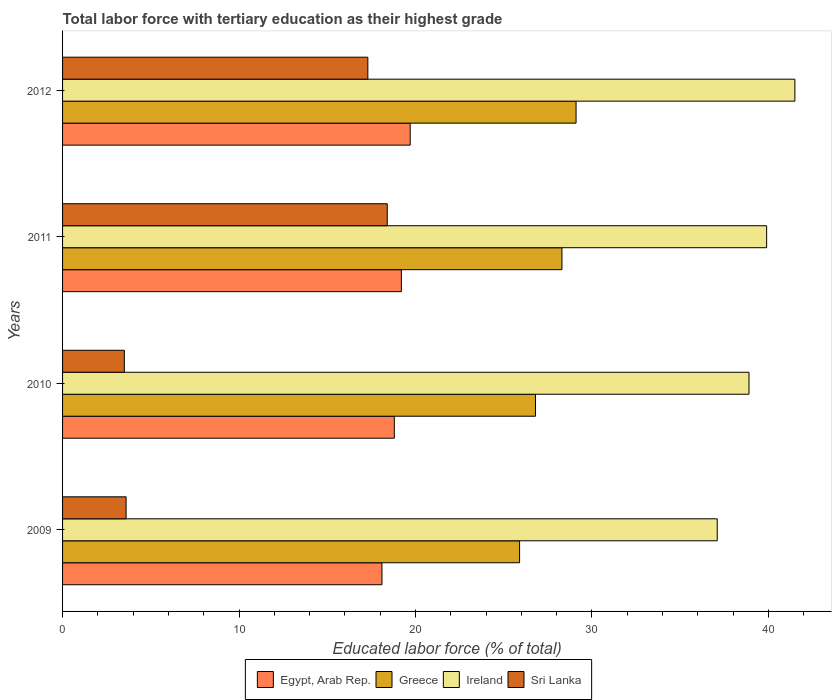How many groups of bars are there?
Your answer should be very brief. 4. Are the number of bars per tick equal to the number of legend labels?
Give a very brief answer. Yes. What is the percentage of male labor force with tertiary education in Ireland in 2009?
Provide a short and direct response. 37.1. Across all years, what is the maximum percentage of male labor force with tertiary education in Greece?
Offer a very short reply. 29.1. Across all years, what is the minimum percentage of male labor force with tertiary education in Sri Lanka?
Your answer should be compact. 3.5. What is the total percentage of male labor force with tertiary education in Ireland in the graph?
Your response must be concise. 157.4. What is the difference between the percentage of male labor force with tertiary education in Sri Lanka in 2009 and that in 2010?
Provide a succinct answer. 0.1. What is the difference between the percentage of male labor force with tertiary education in Egypt, Arab Rep. in 2009 and the percentage of male labor force with tertiary education in Greece in 2011?
Make the answer very short. -10.2. What is the average percentage of male labor force with tertiary education in Ireland per year?
Provide a succinct answer. 39.35. In the year 2011, what is the difference between the percentage of male labor force with tertiary education in Egypt, Arab Rep. and percentage of male labor force with tertiary education in Ireland?
Your answer should be compact. -20.7. What is the ratio of the percentage of male labor force with tertiary education in Greece in 2011 to that in 2012?
Your answer should be very brief. 0.97. Is the percentage of male labor force with tertiary education in Greece in 2009 less than that in 2011?
Offer a terse response. Yes. Is the difference between the percentage of male labor force with tertiary education in Egypt, Arab Rep. in 2011 and 2012 greater than the difference between the percentage of male labor force with tertiary education in Ireland in 2011 and 2012?
Offer a very short reply. Yes. What is the difference between the highest and the second highest percentage of male labor force with tertiary education in Greece?
Your answer should be very brief. 0.8. What is the difference between the highest and the lowest percentage of male labor force with tertiary education in Ireland?
Keep it short and to the point. 4.4. In how many years, is the percentage of male labor force with tertiary education in Egypt, Arab Rep. greater than the average percentage of male labor force with tertiary education in Egypt, Arab Rep. taken over all years?
Make the answer very short. 2. Is it the case that in every year, the sum of the percentage of male labor force with tertiary education in Ireland and percentage of male labor force with tertiary education in Egypt, Arab Rep. is greater than the sum of percentage of male labor force with tertiary education in Greece and percentage of male labor force with tertiary education in Sri Lanka?
Your response must be concise. No. What does the 3rd bar from the top in 2010 represents?
Provide a succinct answer. Greece. What does the 3rd bar from the bottom in 2009 represents?
Make the answer very short. Ireland. Is it the case that in every year, the sum of the percentage of male labor force with tertiary education in Sri Lanka and percentage of male labor force with tertiary education in Egypt, Arab Rep. is greater than the percentage of male labor force with tertiary education in Greece?
Your response must be concise. No. Are all the bars in the graph horizontal?
Offer a very short reply. Yes. How many years are there in the graph?
Keep it short and to the point. 4. Does the graph contain any zero values?
Provide a short and direct response. No. Where does the legend appear in the graph?
Your answer should be compact. Bottom center. What is the title of the graph?
Your answer should be compact. Total labor force with tertiary education as their highest grade. What is the label or title of the X-axis?
Keep it short and to the point. Educated labor force (% of total). What is the label or title of the Y-axis?
Give a very brief answer. Years. What is the Educated labor force (% of total) of Egypt, Arab Rep. in 2009?
Your answer should be very brief. 18.1. What is the Educated labor force (% of total) of Greece in 2009?
Provide a succinct answer. 25.9. What is the Educated labor force (% of total) of Ireland in 2009?
Your response must be concise. 37.1. What is the Educated labor force (% of total) in Sri Lanka in 2009?
Keep it short and to the point. 3.6. What is the Educated labor force (% of total) of Egypt, Arab Rep. in 2010?
Provide a short and direct response. 18.8. What is the Educated labor force (% of total) in Greece in 2010?
Make the answer very short. 26.8. What is the Educated labor force (% of total) of Ireland in 2010?
Make the answer very short. 38.9. What is the Educated labor force (% of total) in Sri Lanka in 2010?
Offer a terse response. 3.5. What is the Educated labor force (% of total) in Egypt, Arab Rep. in 2011?
Ensure brevity in your answer.  19.2. What is the Educated labor force (% of total) in Greece in 2011?
Provide a short and direct response. 28.3. What is the Educated labor force (% of total) of Ireland in 2011?
Keep it short and to the point. 39.9. What is the Educated labor force (% of total) of Sri Lanka in 2011?
Offer a very short reply. 18.4. What is the Educated labor force (% of total) of Egypt, Arab Rep. in 2012?
Your answer should be compact. 19.7. What is the Educated labor force (% of total) in Greece in 2012?
Give a very brief answer. 29.1. What is the Educated labor force (% of total) in Ireland in 2012?
Offer a very short reply. 41.5. What is the Educated labor force (% of total) in Sri Lanka in 2012?
Give a very brief answer. 17.3. Across all years, what is the maximum Educated labor force (% of total) in Egypt, Arab Rep.?
Keep it short and to the point. 19.7. Across all years, what is the maximum Educated labor force (% of total) in Greece?
Your answer should be compact. 29.1. Across all years, what is the maximum Educated labor force (% of total) in Ireland?
Make the answer very short. 41.5. Across all years, what is the maximum Educated labor force (% of total) of Sri Lanka?
Your answer should be compact. 18.4. Across all years, what is the minimum Educated labor force (% of total) of Egypt, Arab Rep.?
Your answer should be very brief. 18.1. Across all years, what is the minimum Educated labor force (% of total) in Greece?
Your response must be concise. 25.9. Across all years, what is the minimum Educated labor force (% of total) in Ireland?
Offer a very short reply. 37.1. Across all years, what is the minimum Educated labor force (% of total) in Sri Lanka?
Provide a succinct answer. 3.5. What is the total Educated labor force (% of total) in Egypt, Arab Rep. in the graph?
Provide a succinct answer. 75.8. What is the total Educated labor force (% of total) of Greece in the graph?
Provide a succinct answer. 110.1. What is the total Educated labor force (% of total) of Ireland in the graph?
Your answer should be compact. 157.4. What is the total Educated labor force (% of total) of Sri Lanka in the graph?
Your answer should be compact. 42.8. What is the difference between the Educated labor force (% of total) in Egypt, Arab Rep. in 2009 and that in 2010?
Your response must be concise. -0.7. What is the difference between the Educated labor force (% of total) in Ireland in 2009 and that in 2010?
Give a very brief answer. -1.8. What is the difference between the Educated labor force (% of total) in Sri Lanka in 2009 and that in 2010?
Offer a terse response. 0.1. What is the difference between the Educated labor force (% of total) of Egypt, Arab Rep. in 2009 and that in 2011?
Give a very brief answer. -1.1. What is the difference between the Educated labor force (% of total) in Sri Lanka in 2009 and that in 2011?
Your answer should be very brief. -14.8. What is the difference between the Educated labor force (% of total) in Egypt, Arab Rep. in 2009 and that in 2012?
Offer a terse response. -1.6. What is the difference between the Educated labor force (% of total) of Sri Lanka in 2009 and that in 2012?
Offer a very short reply. -13.7. What is the difference between the Educated labor force (% of total) of Greece in 2010 and that in 2011?
Give a very brief answer. -1.5. What is the difference between the Educated labor force (% of total) in Sri Lanka in 2010 and that in 2011?
Offer a very short reply. -14.9. What is the difference between the Educated labor force (% of total) in Egypt, Arab Rep. in 2010 and that in 2012?
Provide a succinct answer. -0.9. What is the difference between the Educated labor force (% of total) in Ireland in 2010 and that in 2012?
Your answer should be compact. -2.6. What is the difference between the Educated labor force (% of total) in Egypt, Arab Rep. in 2011 and that in 2012?
Make the answer very short. -0.5. What is the difference between the Educated labor force (% of total) in Sri Lanka in 2011 and that in 2012?
Make the answer very short. 1.1. What is the difference between the Educated labor force (% of total) of Egypt, Arab Rep. in 2009 and the Educated labor force (% of total) of Greece in 2010?
Make the answer very short. -8.7. What is the difference between the Educated labor force (% of total) of Egypt, Arab Rep. in 2009 and the Educated labor force (% of total) of Ireland in 2010?
Make the answer very short. -20.8. What is the difference between the Educated labor force (% of total) of Greece in 2009 and the Educated labor force (% of total) of Sri Lanka in 2010?
Offer a very short reply. 22.4. What is the difference between the Educated labor force (% of total) in Ireland in 2009 and the Educated labor force (% of total) in Sri Lanka in 2010?
Your answer should be compact. 33.6. What is the difference between the Educated labor force (% of total) of Egypt, Arab Rep. in 2009 and the Educated labor force (% of total) of Ireland in 2011?
Keep it short and to the point. -21.8. What is the difference between the Educated labor force (% of total) in Ireland in 2009 and the Educated labor force (% of total) in Sri Lanka in 2011?
Ensure brevity in your answer.  18.7. What is the difference between the Educated labor force (% of total) in Egypt, Arab Rep. in 2009 and the Educated labor force (% of total) in Greece in 2012?
Offer a very short reply. -11. What is the difference between the Educated labor force (% of total) in Egypt, Arab Rep. in 2009 and the Educated labor force (% of total) in Ireland in 2012?
Provide a short and direct response. -23.4. What is the difference between the Educated labor force (% of total) in Greece in 2009 and the Educated labor force (% of total) in Ireland in 2012?
Provide a succinct answer. -15.6. What is the difference between the Educated labor force (% of total) of Ireland in 2009 and the Educated labor force (% of total) of Sri Lanka in 2012?
Your answer should be compact. 19.8. What is the difference between the Educated labor force (% of total) in Egypt, Arab Rep. in 2010 and the Educated labor force (% of total) in Greece in 2011?
Ensure brevity in your answer.  -9.5. What is the difference between the Educated labor force (% of total) in Egypt, Arab Rep. in 2010 and the Educated labor force (% of total) in Ireland in 2011?
Your response must be concise. -21.1. What is the difference between the Educated labor force (% of total) in Egypt, Arab Rep. in 2010 and the Educated labor force (% of total) in Ireland in 2012?
Provide a short and direct response. -22.7. What is the difference between the Educated labor force (% of total) in Egypt, Arab Rep. in 2010 and the Educated labor force (% of total) in Sri Lanka in 2012?
Your response must be concise. 1.5. What is the difference between the Educated labor force (% of total) of Greece in 2010 and the Educated labor force (% of total) of Ireland in 2012?
Provide a short and direct response. -14.7. What is the difference between the Educated labor force (% of total) of Greece in 2010 and the Educated labor force (% of total) of Sri Lanka in 2012?
Provide a short and direct response. 9.5. What is the difference between the Educated labor force (% of total) in Ireland in 2010 and the Educated labor force (% of total) in Sri Lanka in 2012?
Offer a terse response. 21.6. What is the difference between the Educated labor force (% of total) of Egypt, Arab Rep. in 2011 and the Educated labor force (% of total) of Ireland in 2012?
Offer a terse response. -22.3. What is the difference between the Educated labor force (% of total) of Greece in 2011 and the Educated labor force (% of total) of Ireland in 2012?
Keep it short and to the point. -13.2. What is the difference between the Educated labor force (% of total) of Ireland in 2011 and the Educated labor force (% of total) of Sri Lanka in 2012?
Provide a succinct answer. 22.6. What is the average Educated labor force (% of total) in Egypt, Arab Rep. per year?
Make the answer very short. 18.95. What is the average Educated labor force (% of total) in Greece per year?
Your response must be concise. 27.52. What is the average Educated labor force (% of total) of Ireland per year?
Your answer should be very brief. 39.35. What is the average Educated labor force (% of total) of Sri Lanka per year?
Offer a terse response. 10.7. In the year 2009, what is the difference between the Educated labor force (% of total) in Greece and Educated labor force (% of total) in Ireland?
Make the answer very short. -11.2. In the year 2009, what is the difference between the Educated labor force (% of total) in Greece and Educated labor force (% of total) in Sri Lanka?
Your answer should be compact. 22.3. In the year 2009, what is the difference between the Educated labor force (% of total) in Ireland and Educated labor force (% of total) in Sri Lanka?
Ensure brevity in your answer.  33.5. In the year 2010, what is the difference between the Educated labor force (% of total) in Egypt, Arab Rep. and Educated labor force (% of total) in Ireland?
Make the answer very short. -20.1. In the year 2010, what is the difference between the Educated labor force (% of total) in Egypt, Arab Rep. and Educated labor force (% of total) in Sri Lanka?
Provide a short and direct response. 15.3. In the year 2010, what is the difference between the Educated labor force (% of total) in Greece and Educated labor force (% of total) in Ireland?
Make the answer very short. -12.1. In the year 2010, what is the difference between the Educated labor force (% of total) of Greece and Educated labor force (% of total) of Sri Lanka?
Your response must be concise. 23.3. In the year 2010, what is the difference between the Educated labor force (% of total) in Ireland and Educated labor force (% of total) in Sri Lanka?
Make the answer very short. 35.4. In the year 2011, what is the difference between the Educated labor force (% of total) of Egypt, Arab Rep. and Educated labor force (% of total) of Greece?
Keep it short and to the point. -9.1. In the year 2011, what is the difference between the Educated labor force (% of total) of Egypt, Arab Rep. and Educated labor force (% of total) of Ireland?
Ensure brevity in your answer.  -20.7. In the year 2012, what is the difference between the Educated labor force (% of total) of Egypt, Arab Rep. and Educated labor force (% of total) of Greece?
Provide a succinct answer. -9.4. In the year 2012, what is the difference between the Educated labor force (% of total) in Egypt, Arab Rep. and Educated labor force (% of total) in Ireland?
Ensure brevity in your answer.  -21.8. In the year 2012, what is the difference between the Educated labor force (% of total) in Egypt, Arab Rep. and Educated labor force (% of total) in Sri Lanka?
Offer a terse response. 2.4. In the year 2012, what is the difference between the Educated labor force (% of total) in Greece and Educated labor force (% of total) in Ireland?
Ensure brevity in your answer.  -12.4. In the year 2012, what is the difference between the Educated labor force (% of total) of Greece and Educated labor force (% of total) of Sri Lanka?
Ensure brevity in your answer.  11.8. In the year 2012, what is the difference between the Educated labor force (% of total) in Ireland and Educated labor force (% of total) in Sri Lanka?
Give a very brief answer. 24.2. What is the ratio of the Educated labor force (% of total) of Egypt, Arab Rep. in 2009 to that in 2010?
Offer a terse response. 0.96. What is the ratio of the Educated labor force (% of total) of Greece in 2009 to that in 2010?
Make the answer very short. 0.97. What is the ratio of the Educated labor force (% of total) in Ireland in 2009 to that in 2010?
Give a very brief answer. 0.95. What is the ratio of the Educated labor force (% of total) in Sri Lanka in 2009 to that in 2010?
Your answer should be very brief. 1.03. What is the ratio of the Educated labor force (% of total) of Egypt, Arab Rep. in 2009 to that in 2011?
Your answer should be very brief. 0.94. What is the ratio of the Educated labor force (% of total) of Greece in 2009 to that in 2011?
Offer a terse response. 0.92. What is the ratio of the Educated labor force (% of total) in Ireland in 2009 to that in 2011?
Your answer should be compact. 0.93. What is the ratio of the Educated labor force (% of total) in Sri Lanka in 2009 to that in 2011?
Provide a short and direct response. 0.2. What is the ratio of the Educated labor force (% of total) in Egypt, Arab Rep. in 2009 to that in 2012?
Your answer should be compact. 0.92. What is the ratio of the Educated labor force (% of total) of Greece in 2009 to that in 2012?
Keep it short and to the point. 0.89. What is the ratio of the Educated labor force (% of total) of Ireland in 2009 to that in 2012?
Your answer should be compact. 0.89. What is the ratio of the Educated labor force (% of total) of Sri Lanka in 2009 to that in 2012?
Offer a very short reply. 0.21. What is the ratio of the Educated labor force (% of total) in Egypt, Arab Rep. in 2010 to that in 2011?
Your answer should be compact. 0.98. What is the ratio of the Educated labor force (% of total) in Greece in 2010 to that in 2011?
Give a very brief answer. 0.95. What is the ratio of the Educated labor force (% of total) of Ireland in 2010 to that in 2011?
Keep it short and to the point. 0.97. What is the ratio of the Educated labor force (% of total) in Sri Lanka in 2010 to that in 2011?
Provide a succinct answer. 0.19. What is the ratio of the Educated labor force (% of total) in Egypt, Arab Rep. in 2010 to that in 2012?
Provide a short and direct response. 0.95. What is the ratio of the Educated labor force (% of total) in Greece in 2010 to that in 2012?
Keep it short and to the point. 0.92. What is the ratio of the Educated labor force (% of total) in Ireland in 2010 to that in 2012?
Your answer should be very brief. 0.94. What is the ratio of the Educated labor force (% of total) in Sri Lanka in 2010 to that in 2012?
Ensure brevity in your answer.  0.2. What is the ratio of the Educated labor force (% of total) in Egypt, Arab Rep. in 2011 to that in 2012?
Your answer should be very brief. 0.97. What is the ratio of the Educated labor force (% of total) in Greece in 2011 to that in 2012?
Ensure brevity in your answer.  0.97. What is the ratio of the Educated labor force (% of total) in Ireland in 2011 to that in 2012?
Give a very brief answer. 0.96. What is the ratio of the Educated labor force (% of total) in Sri Lanka in 2011 to that in 2012?
Make the answer very short. 1.06. What is the difference between the highest and the second highest Educated labor force (% of total) in Egypt, Arab Rep.?
Provide a short and direct response. 0.5. What is the difference between the highest and the second highest Educated labor force (% of total) of Greece?
Ensure brevity in your answer.  0.8. What is the difference between the highest and the lowest Educated labor force (% of total) in Greece?
Your answer should be very brief. 3.2. What is the difference between the highest and the lowest Educated labor force (% of total) in Ireland?
Keep it short and to the point. 4.4. 